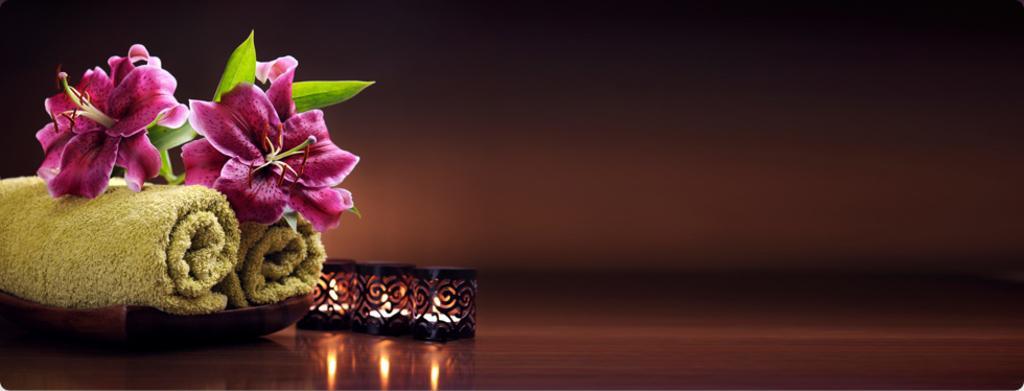In one or two sentences, can you explain what this image depicts? On the left side of the image we can see flowers and napkins in the plate, beside the plate we can find lights. 